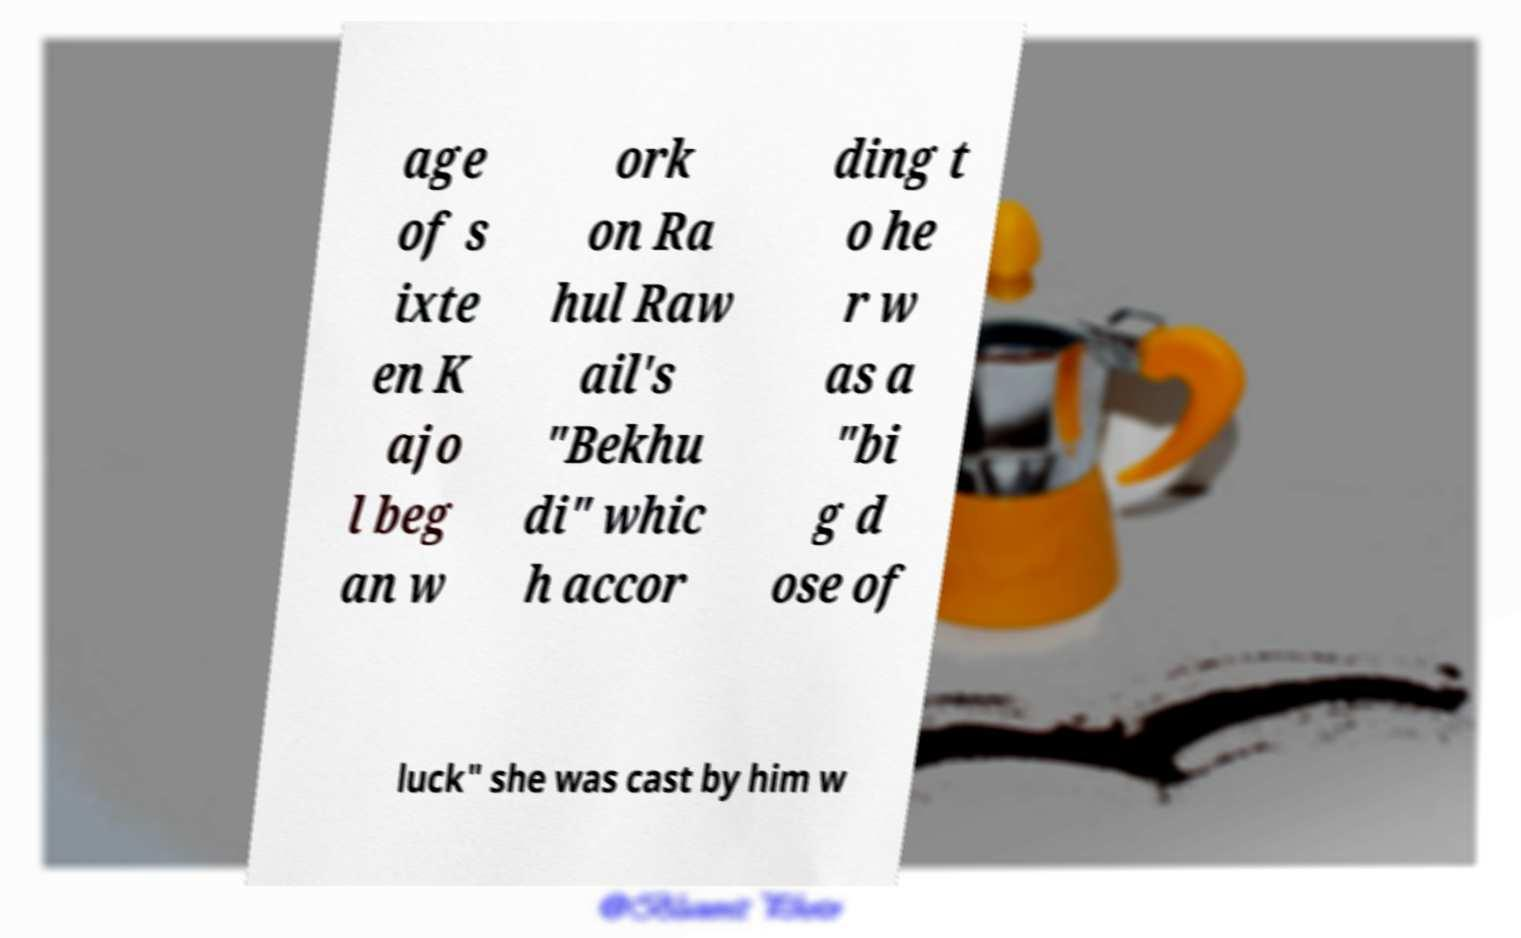Please identify and transcribe the text found in this image. age of s ixte en K ajo l beg an w ork on Ra hul Raw ail's "Bekhu di" whic h accor ding t o he r w as a "bi g d ose of luck" she was cast by him w 